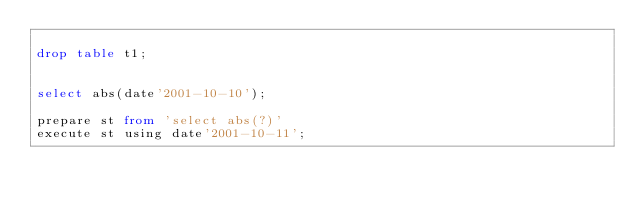<code> <loc_0><loc_0><loc_500><loc_500><_SQL_>
drop table t1;


select abs(date'2001-10-10');

prepare st from 'select abs(?)'
execute st using date'2001-10-11';


</code> 